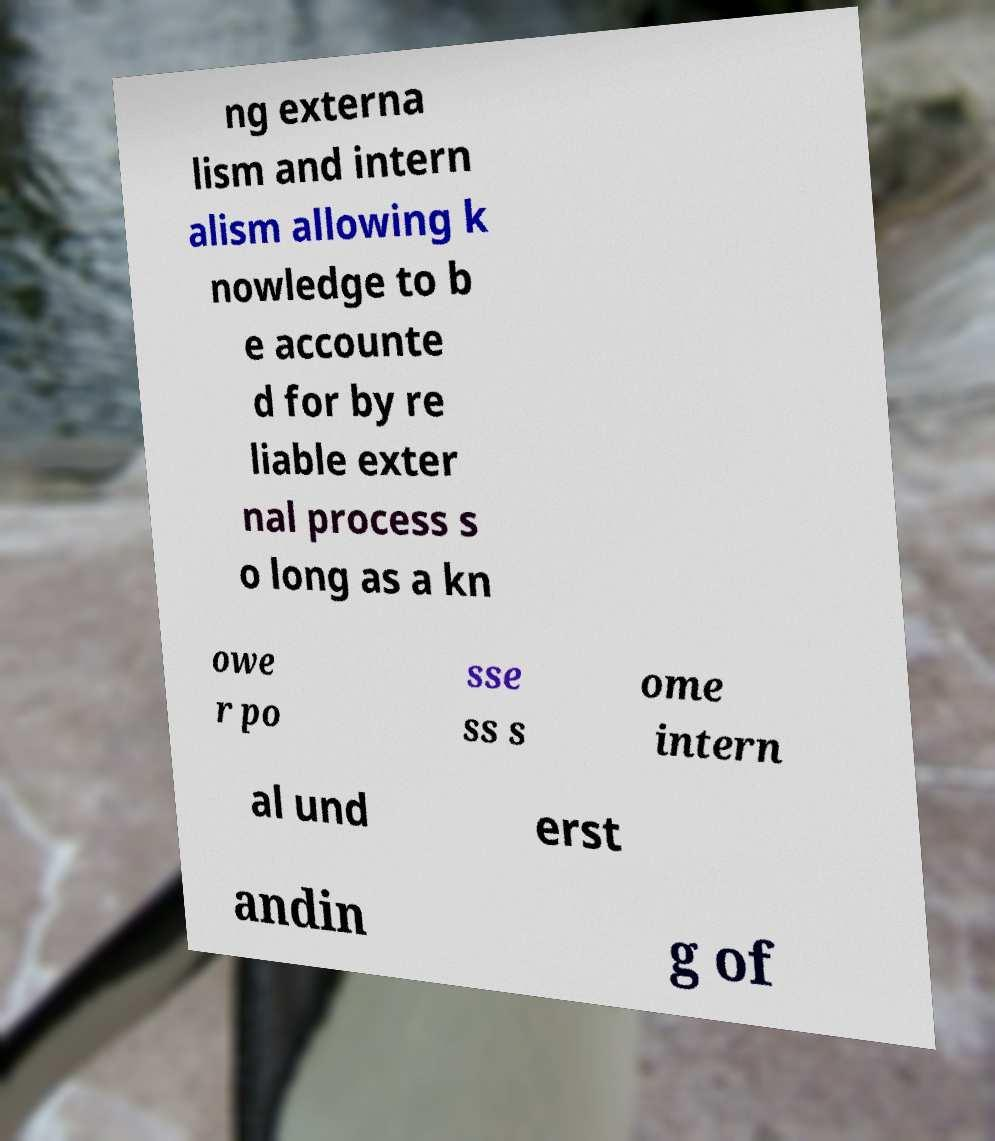Please read and relay the text visible in this image. What does it say? ng externa lism and intern alism allowing k nowledge to b e accounte d for by re liable exter nal process s o long as a kn owe r po sse ss s ome intern al und erst andin g of 